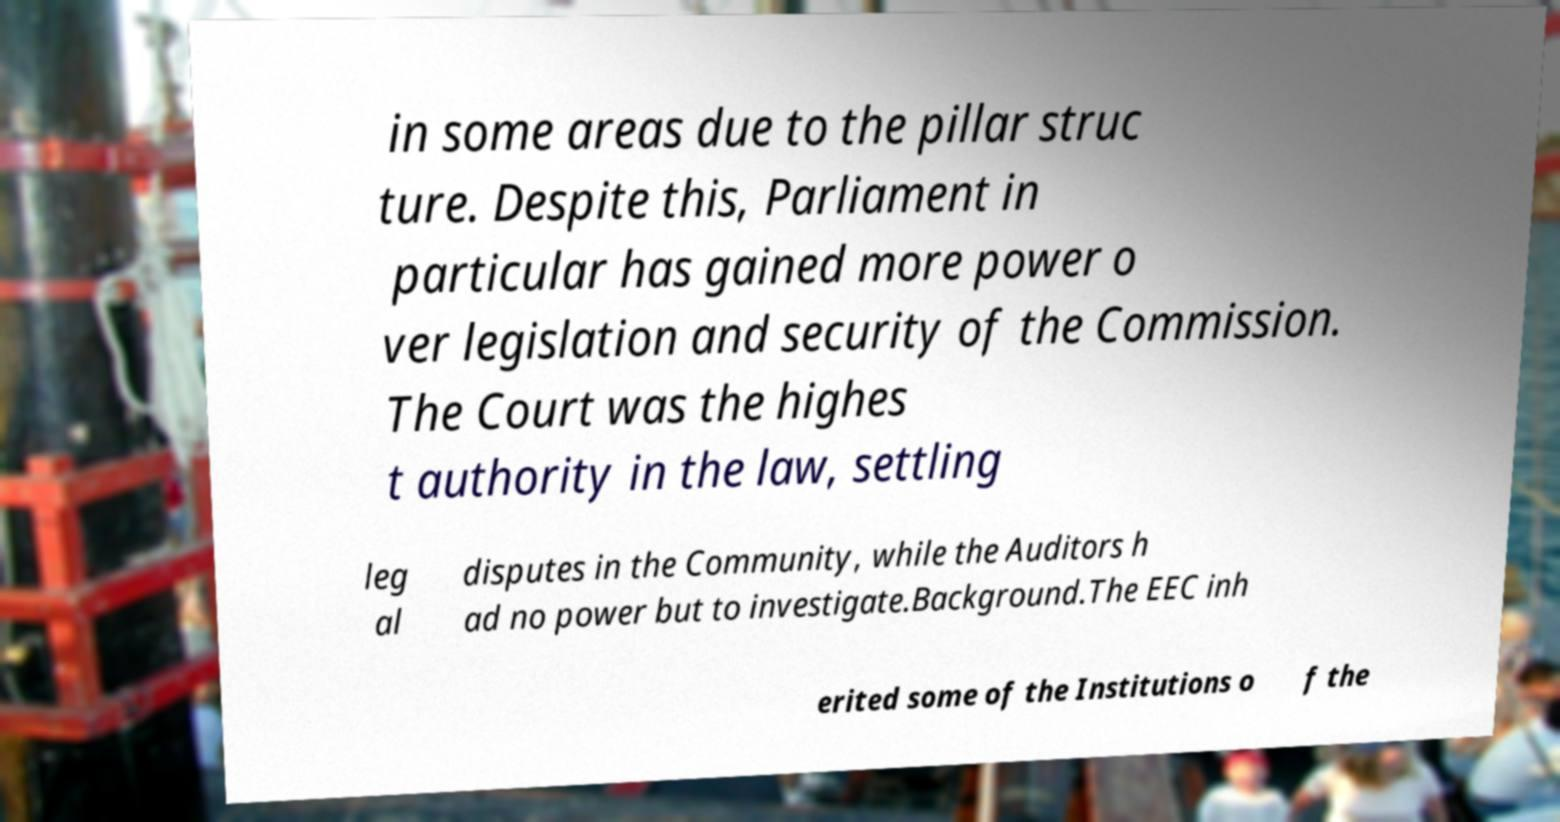Please identify and transcribe the text found in this image. in some areas due to the pillar struc ture. Despite this, Parliament in particular has gained more power o ver legislation and security of the Commission. The Court was the highes t authority in the law, settling leg al disputes in the Community, while the Auditors h ad no power but to investigate.Background.The EEC inh erited some of the Institutions o f the 